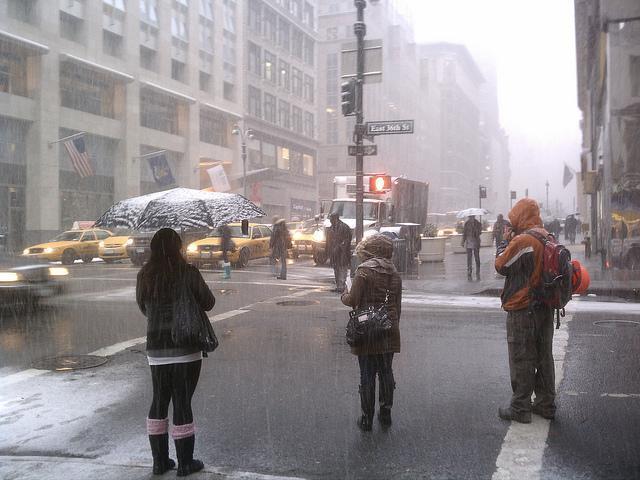How many people are standing in the cross walk?
Give a very brief answer. 3. How many cars can you see?
Give a very brief answer. 3. How many people can be seen?
Give a very brief answer. 3. 